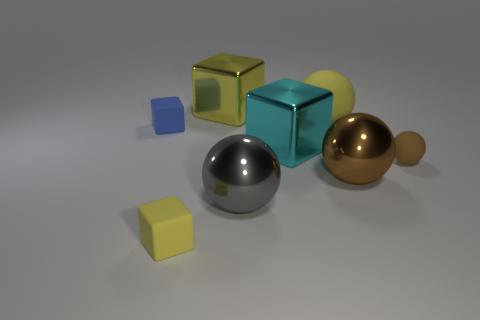Add 1 large brown matte blocks. How many objects exist? 9 Subtract 1 gray balls. How many objects are left? 7 Subtract all gray things. Subtract all yellow cubes. How many objects are left? 5 Add 6 large brown metal balls. How many large brown metal balls are left? 7 Add 4 big red metal cubes. How many big red metal cubes exist? 4 